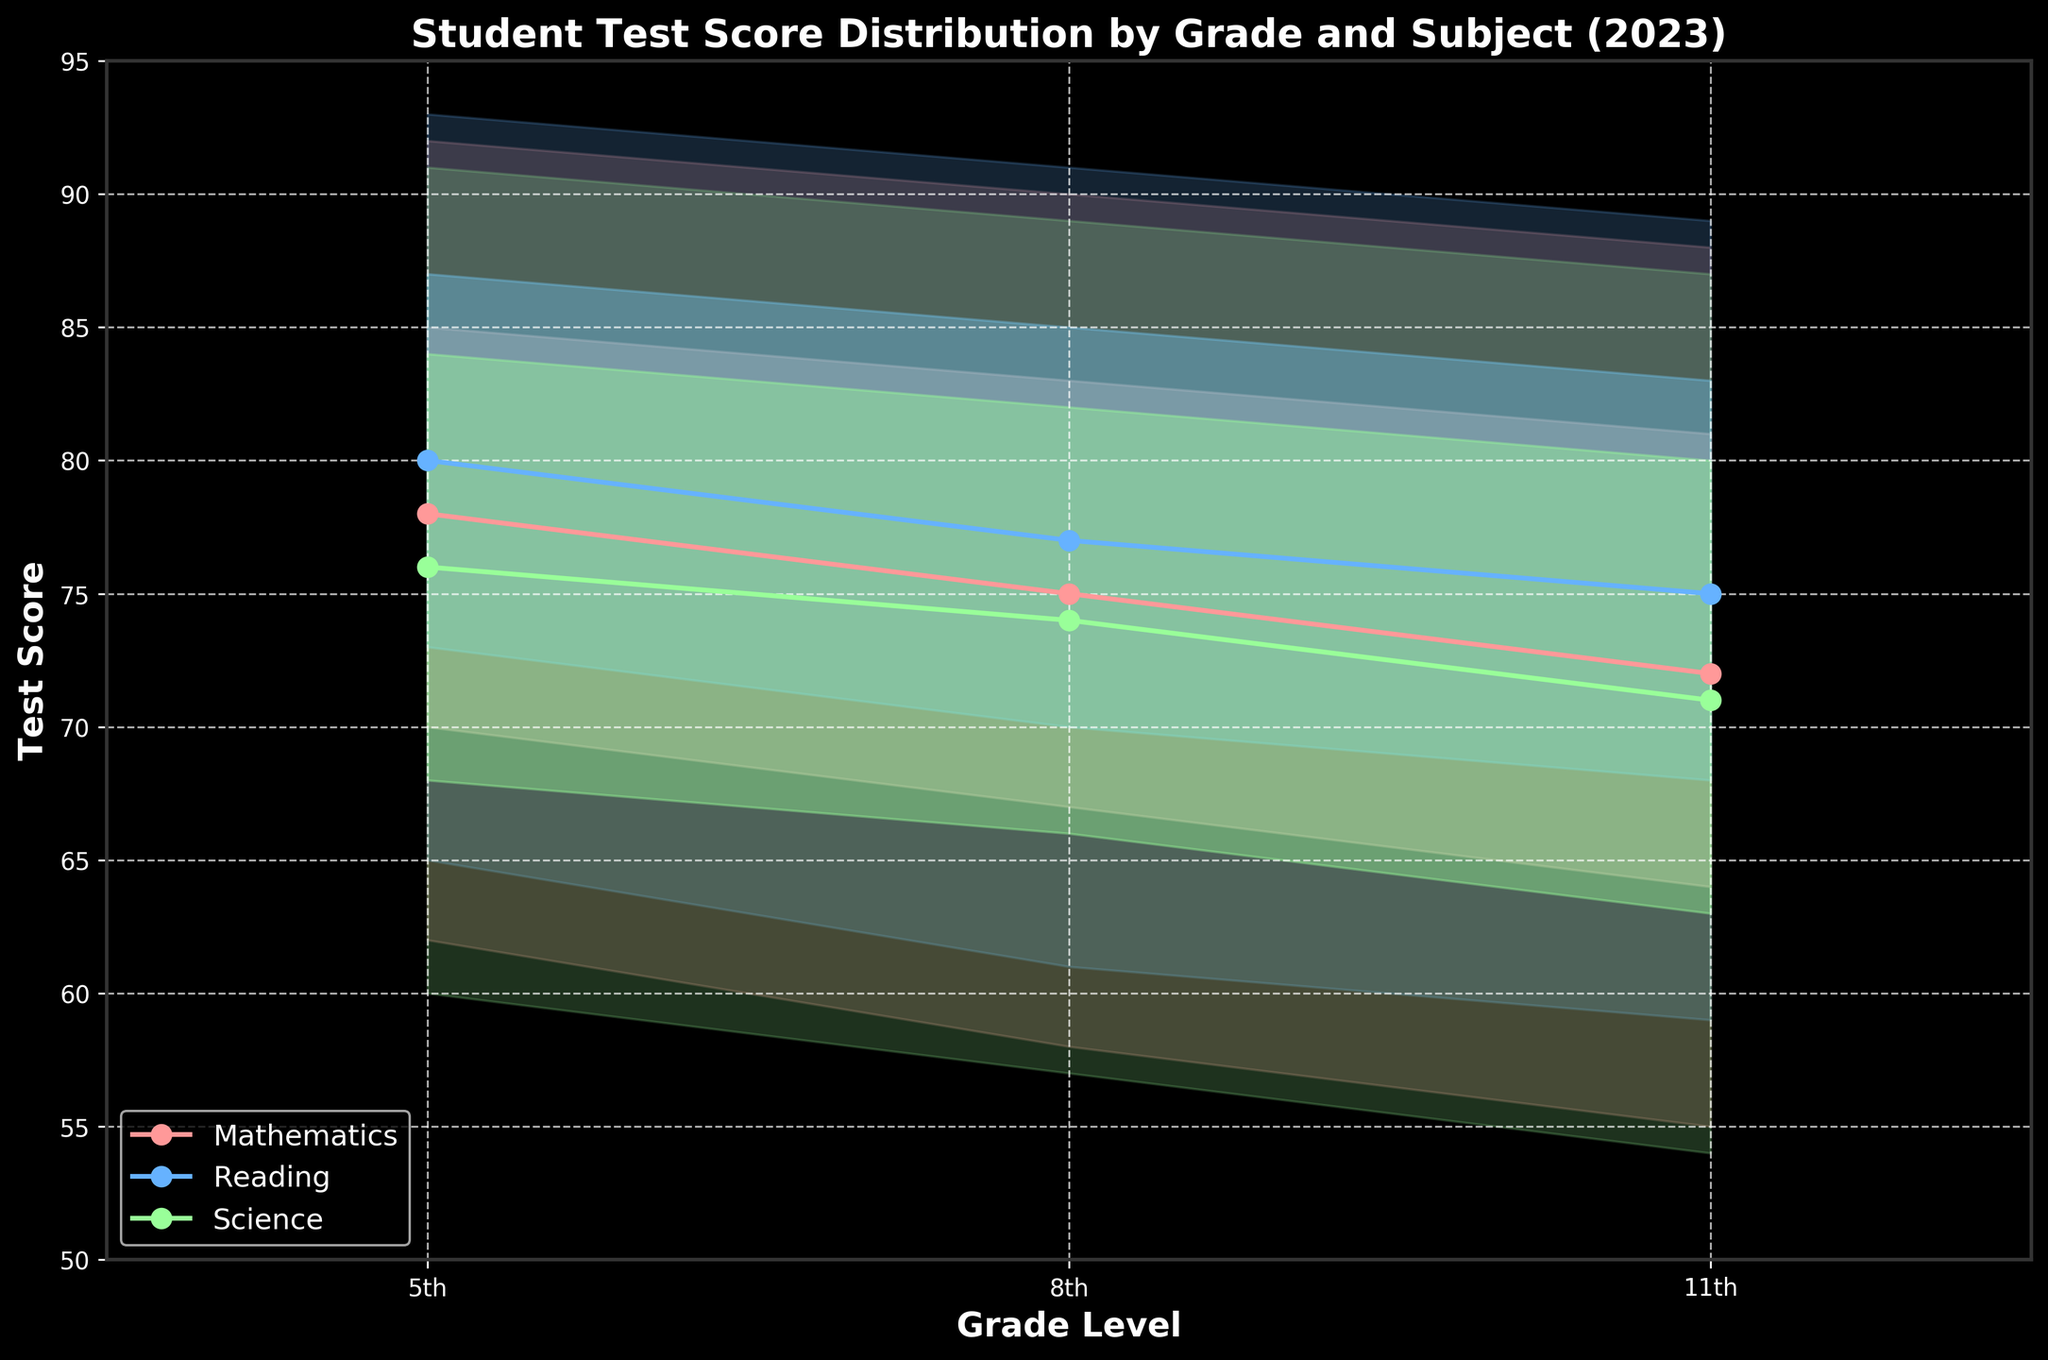What is the median test score in Mathematics for 8th grade? The median test score for each subject and grade is represented by the middle line within the fan chart. For Mathematics in 8th grade, the median score is shown directly on the chart.
Answer: 75 Between which grade levels does the median test score for Science decline the most? Analyze the median lines for Science at each grade level and calculate the difference in the scores between successive grades (5th to 8th and 8th to 11th). Compare the differences to determine which is greatest.
Answer: 5th to 8th Which subject has the highest median test score for 11th grade? Compare the median test scores (middle lines in the fan chart) for each subject at the 11th grade. Identify the highest value among them.
Answer: Reading In 5th grade, which subject has the narrowest range between the 10th and 90th percentiles? For each subject at the 5th grade level, calculate the difference between the 90th and 10th percentiles and find the smallest difference.
Answer: Reading By how many points does the 75th percentile test score in Mathematics decrease from 5th to 11th grade? Subtract the 75th percentile score of Mathematics in 11th grade from the 75th percentile score in 5th grade (85 - 81).
Answer: 4 Which subject shows the largest spread (difference between 10th and 90th percentiles) for 8th grade? Calculate the spread (90th percentile minus 10th percentile) for each subject at the 8th grade and determine which is the largest.
Answer: Reading What is the overall title of the figure? The title of the figure is displayed at the top centre, summarising the content shown in the chart.
Answer: Student Test Score Distribution by Grade and Subject (2023) Which subject has the smallest decrease in the median score from 5th to 11th grade? Subtract the median scores for each subject in 11th grade from those in 5th grade. Compare the decreases and identify the smallest one.
Answer: Reading In 2023, for which subject do students show the highest performance variability in 11th grade? The variability can be judged by looking at the width of the shaded areas between the 10th and 90th percentiles. Identify the subject with the widest band.
Answer: Reading How does the spread between the 25th and 75th percentiles for Science change from 8th to 11th grade? Compare the difference between the 25th and 75th percentiles for Science in 8th and 11th grades to see if it increases or decreases.
Answer: Decreases 